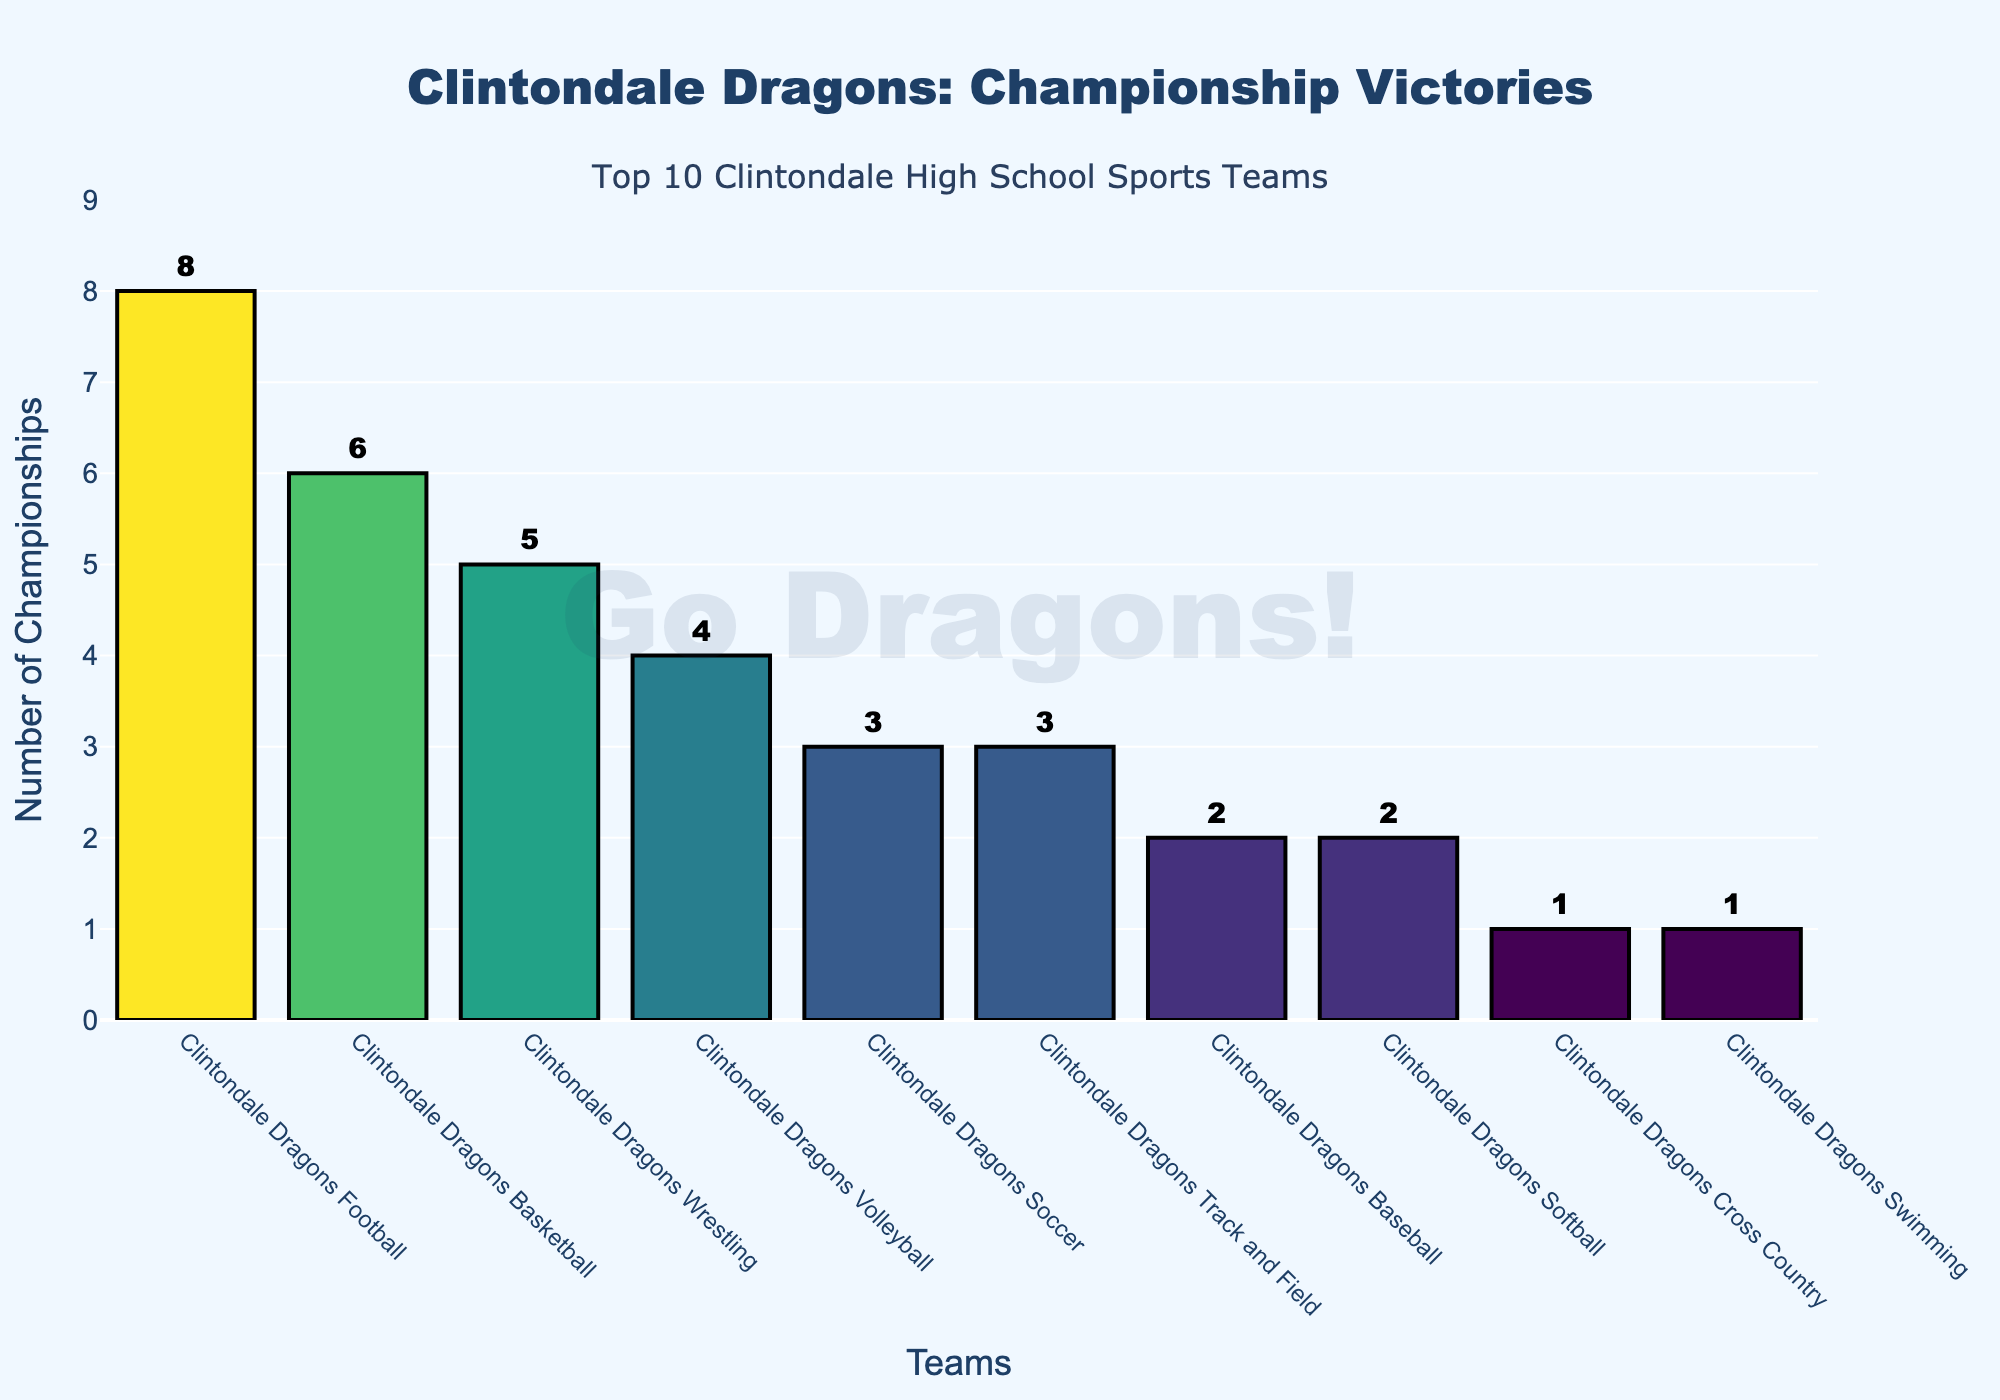Which Clintondale High School sports team has the most championship wins? The bar chart shows that the Clintondale Dragons Football team has the most championship wins with 8.
Answer: Clintondale Dragons Football Which team has more championship wins, Basketball or Volleyball? The chart displays that the Clintondale Dragons Basketball team has 6 championship wins, while the Volleyball team has 4. Thus, Basketball has more wins.
Answer: Basketball How many total championship wins do the Track and Field, Baseball, and Cross Country teams have combined? According to the chart, the Track and Field team has 3 wins, Baseball has 2, and Cross Country has 1. Summing them up: 3 + 2 + 1 = 6.
Answer: 6 Which team is ranked third in terms of championship wins? The chart shows the Clintondale Dragons Wrestling team ranks third with 5 championship wins.
Answer: Clintondale Dragons Wrestling What is the difference in the number of championship wins between the team with the highest wins and the team with the lowest wins? The Football team has the highest wins with 8, and both the Cross Country and Swimming teams have the lowest with 1 win each. The difference is 8 - 1 = 7.
Answer: 7 Which teams have won exactly 2 championships? The chart shows that the Clintondale Dragons Baseball and Softball teams have each won 2 championships.
Answer: Baseball, Softball Is the championship count of the Wrestling team closer to the Volleyball team or the Soccer team? The Wrestling team has 5 wins, Volleyball has 4, and Soccer has 3. The difference between Wrestling and Volleyball is 1 (5-4) and between Wrestling and Soccer is 2 (5-3). Thus, it's closer to Volleyball.
Answer: Volleyball What is the total number of championship wins across all teams listed? Summing all the individual championship wins: 8 (Football) + 6 (Basketball) + 5 (Wrestling) + 4 (Volleyball) + 3 (Soccer) + 3 (Track and Field) + 2 (Baseball) + 2 (Softball) + 1 (Cross Country) + 1 (Swimming) = 35.
Answer: 35 Between Soccer and Basketball, which team has fewer championship wins and by how many? The Basketball team has 6 wins, and the Soccer team has 3 wins. Soccer has fewer wins, and the difference is 6 - 3 = 3 wins.
Answer: Soccer, 3 